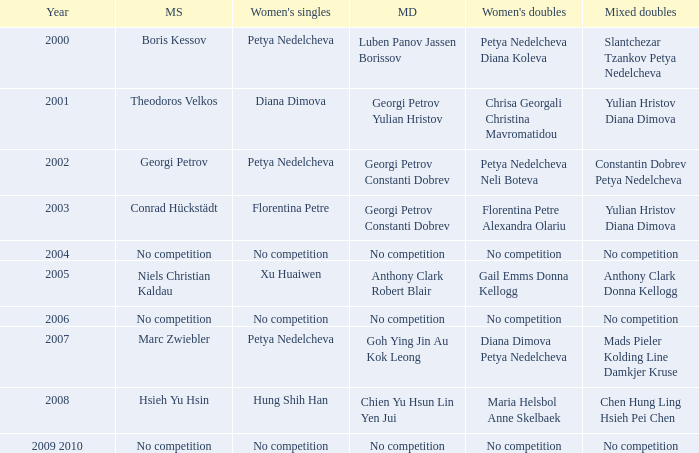Parse the table in full. {'header': ['Year', 'MS', "Women's singles", 'MD', "Women's doubles", 'Mixed doubles'], 'rows': [['2000', 'Boris Kessov', 'Petya Nedelcheva', 'Luben Panov Jassen Borissov', 'Petya Nedelcheva Diana Koleva', 'Slantchezar Tzankov Petya Nedelcheva'], ['2001', 'Theodoros Velkos', 'Diana Dimova', 'Georgi Petrov Yulian Hristov', 'Chrisa Georgali Christina Mavromatidou', 'Yulian Hristov Diana Dimova'], ['2002', 'Georgi Petrov', 'Petya Nedelcheva', 'Georgi Petrov Constanti Dobrev', 'Petya Nedelcheva Neli Boteva', 'Constantin Dobrev Petya Nedelcheva'], ['2003', 'Conrad Hückstädt', 'Florentina Petre', 'Georgi Petrov Constanti Dobrev', 'Florentina Petre Alexandra Olariu', 'Yulian Hristov Diana Dimova'], ['2004', 'No competition', 'No competition', 'No competition', 'No competition', 'No competition'], ['2005', 'Niels Christian Kaldau', 'Xu Huaiwen', 'Anthony Clark Robert Blair', 'Gail Emms Donna Kellogg', 'Anthony Clark Donna Kellogg'], ['2006', 'No competition', 'No competition', 'No competition', 'No competition', 'No competition'], ['2007', 'Marc Zwiebler', 'Petya Nedelcheva', 'Goh Ying Jin Au Kok Leong', 'Diana Dimova Petya Nedelcheva', 'Mads Pieler Kolding Line Damkjer Kruse'], ['2008', 'Hsieh Yu Hsin', 'Hung Shih Han', 'Chien Yu Hsun Lin Yen Jui', 'Maria Helsbol Anne Skelbaek', 'Chen Hung Ling Hsieh Pei Chen'], ['2009 2010', 'No competition', 'No competition', 'No competition', 'No competition', 'No competition']]} Who won the Men's Double the same year as Florentina Petre winning the Women's Singles? Georgi Petrov Constanti Dobrev. 